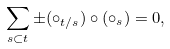<formula> <loc_0><loc_0><loc_500><loc_500>\sum _ { s \subset t } \pm ( \circ _ { t / s } ) \circ ( \circ _ { s } ) = 0 ,</formula> 